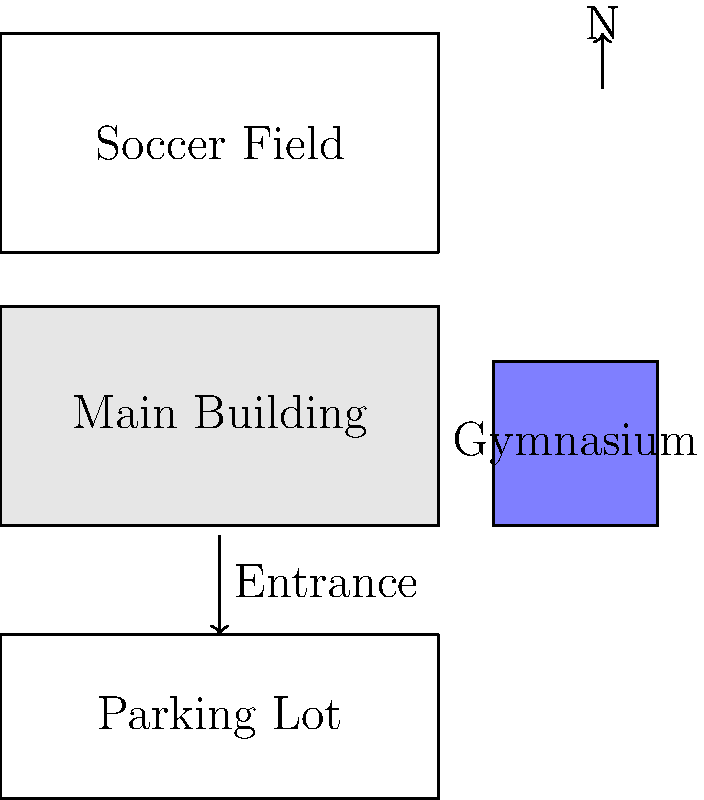Based on the simple map of Rahway 7th & 8th Grade Academy campus, which direction is the soccer field located in relation to the main building? To determine the direction of the soccer field in relation to the main building, we need to follow these steps:

1. Identify the main building on the map. It's the large rectangular structure labeled "Main Building" in the center of the map.

2. Locate the soccer field on the map. It's the rectangular area labeled "Soccer Field" above the main building.

3. Observe the north arrow on the map. It's located in the upper right corner, pointing upwards.

4. Determine the relative position of the soccer field to the main building. The soccer field is positioned above the main building on the map.

5. Correlate the relative position with the cardinal directions. Since north is indicated as upwards on the map, and the soccer field is above the main building, we can conclude that the soccer field is north of the main building.

This layout provides a general understanding of the campus arrangement, which could be useful for community members interested in school events or activities held in these areas.
Answer: North 